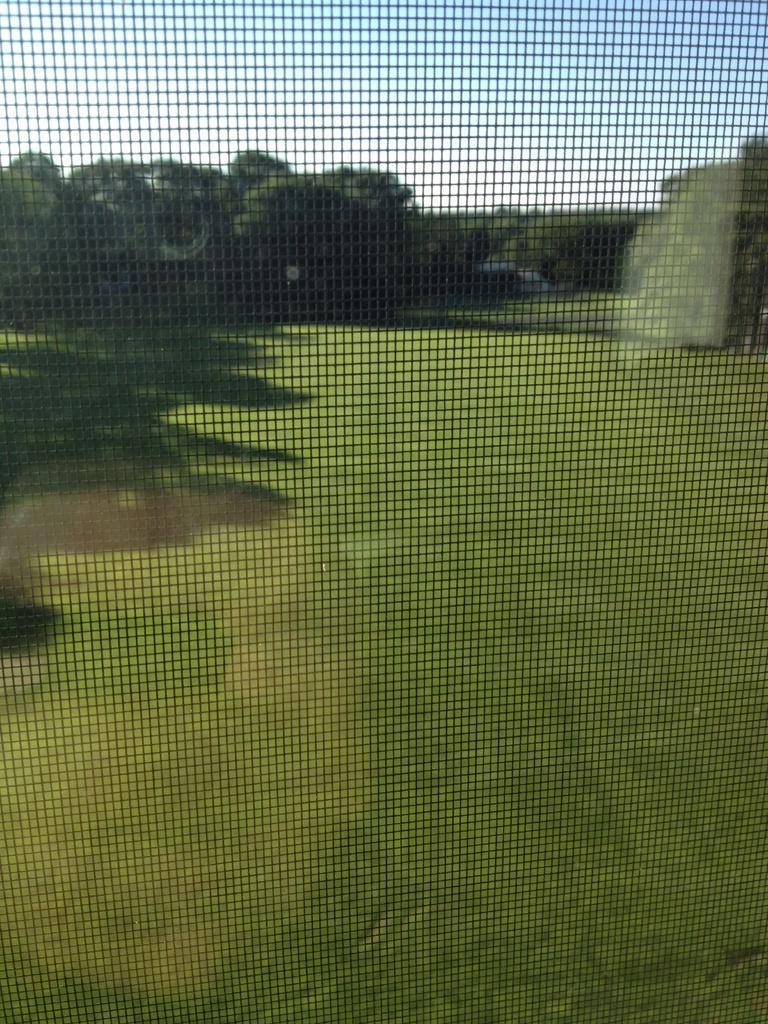In one or two sentences, can you explain what this image depicts? At the forefront of this image, there is a net. Through this net, we can see there are trees and grass on the ground and there are clouds in the sky. 